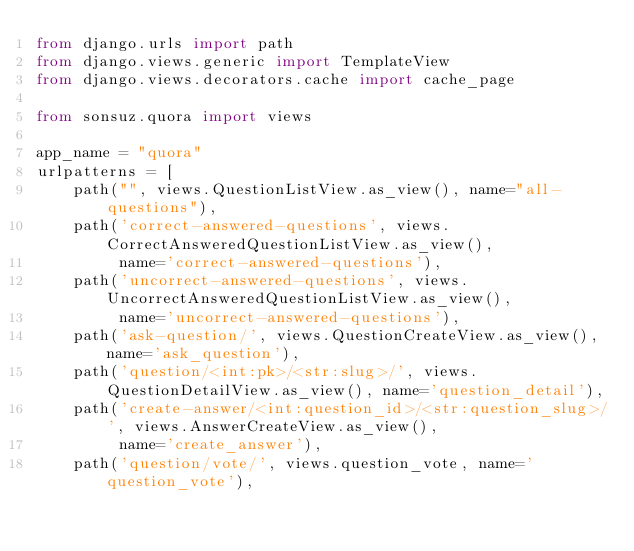<code> <loc_0><loc_0><loc_500><loc_500><_Python_>from django.urls import path
from django.views.generic import TemplateView
from django.views.decorators.cache import cache_page

from sonsuz.quora import views

app_name = "quora"
urlpatterns = [
    path("", views.QuestionListView.as_view(), name="all-questions"),
    path('correct-answered-questions', views.CorrectAnsweredQuestionListView.as_view(),
         name='correct-answered-questions'),
    path('uncorrect-answered-questions', views.UncorrectAnsweredQuestionListView.as_view(),
         name='uncorrect-answered-questions'),
    path('ask-question/', views.QuestionCreateView.as_view(), name='ask_question'),
    path('question/<int:pk>/<str:slug>/', views.QuestionDetailView.as_view(), name='question_detail'),
    path('create-answer/<int:question_id>/<str:question_slug>/', views.AnswerCreateView.as_view(),
         name='create_answer'),
    path('question/vote/', views.question_vote, name='question_vote'),</code> 